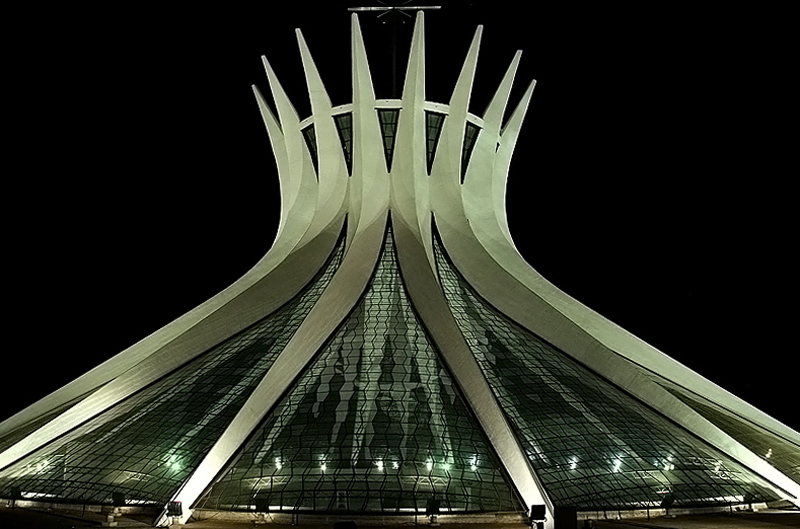How does the design of this structure reflect its likely cultural or symbolic significance? The design of the structure is quite unique, featuring upward-sweeping curves that may symbolize growth, aspiration, or a reach towards the sky. Its appearance resembles a crown or a blooming flower, which could be reflective of cultural symbolism tied to celebration, royalty, or national pride. Such architectural choices are often deliberate, aiming to convey specific messages or emotions. 